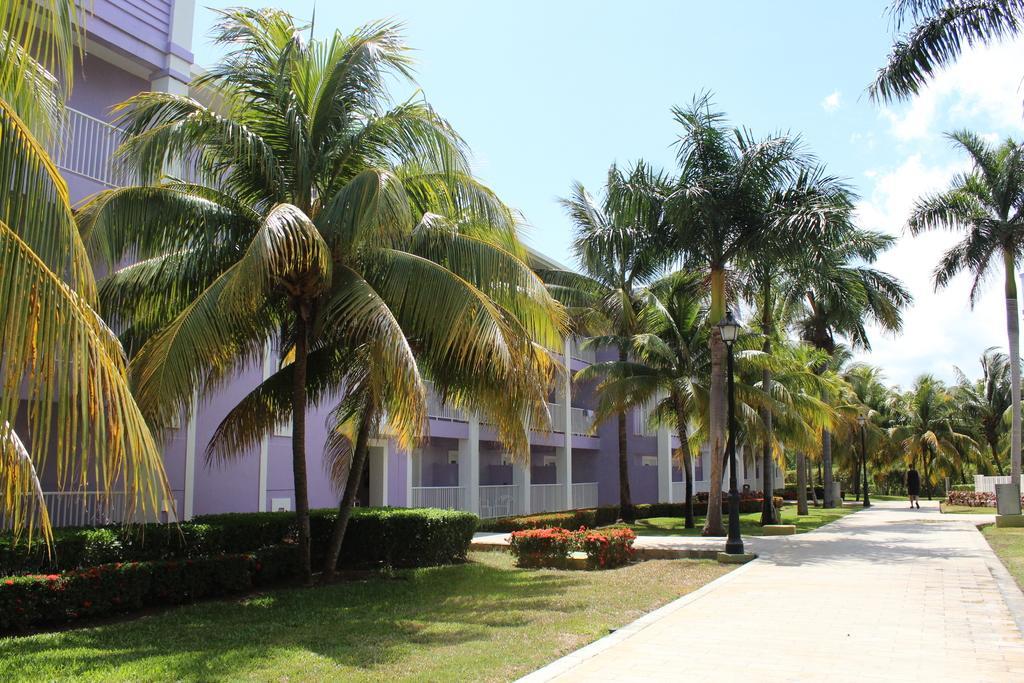Can you describe this image briefly? In this image we can see a person is walking on the road, we can see grass, shrubs, trees, light poles, building and the sky with clouds in the background. 